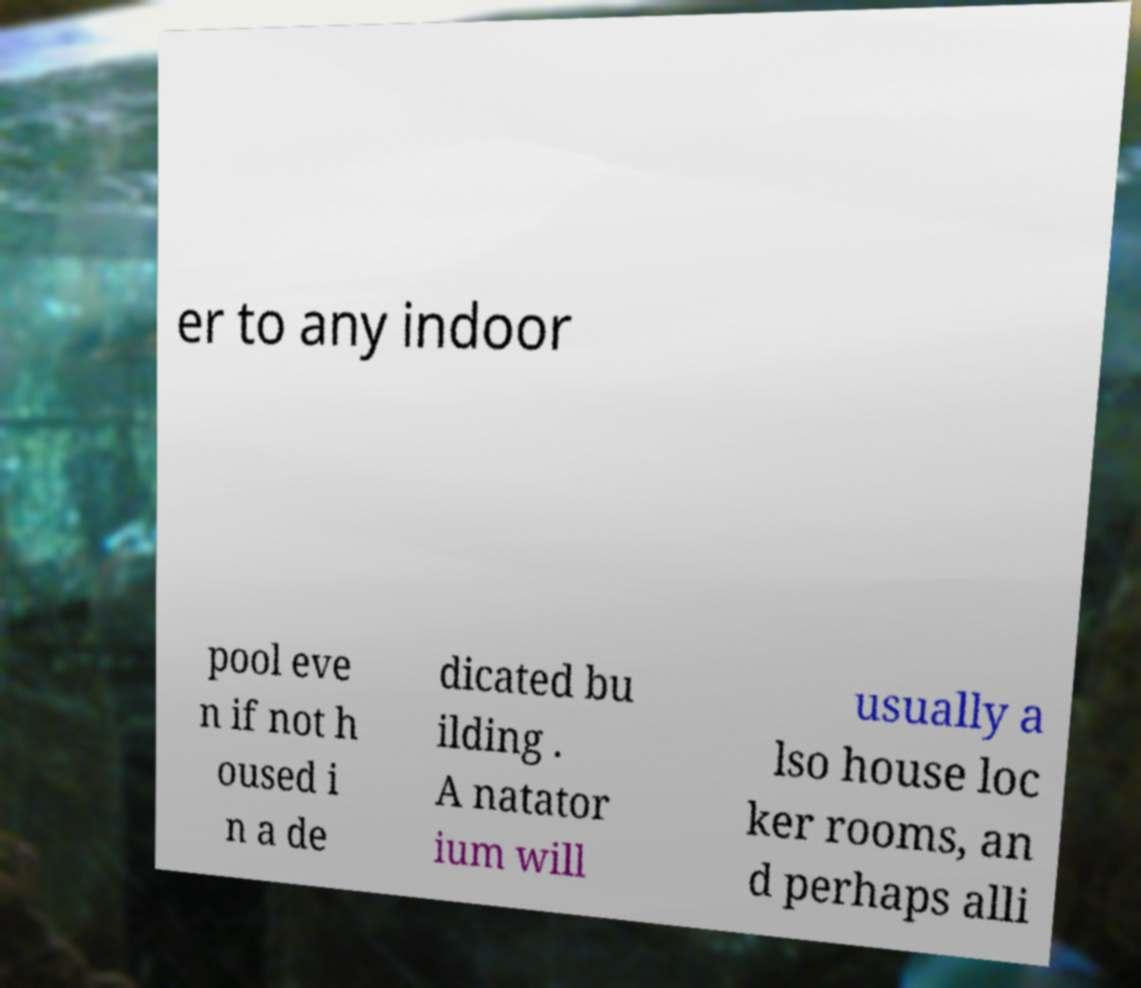Could you extract and type out the text from this image? er to any indoor pool eve n if not h oused i n a de dicated bu ilding . A natator ium will usually a lso house loc ker rooms, an d perhaps alli 